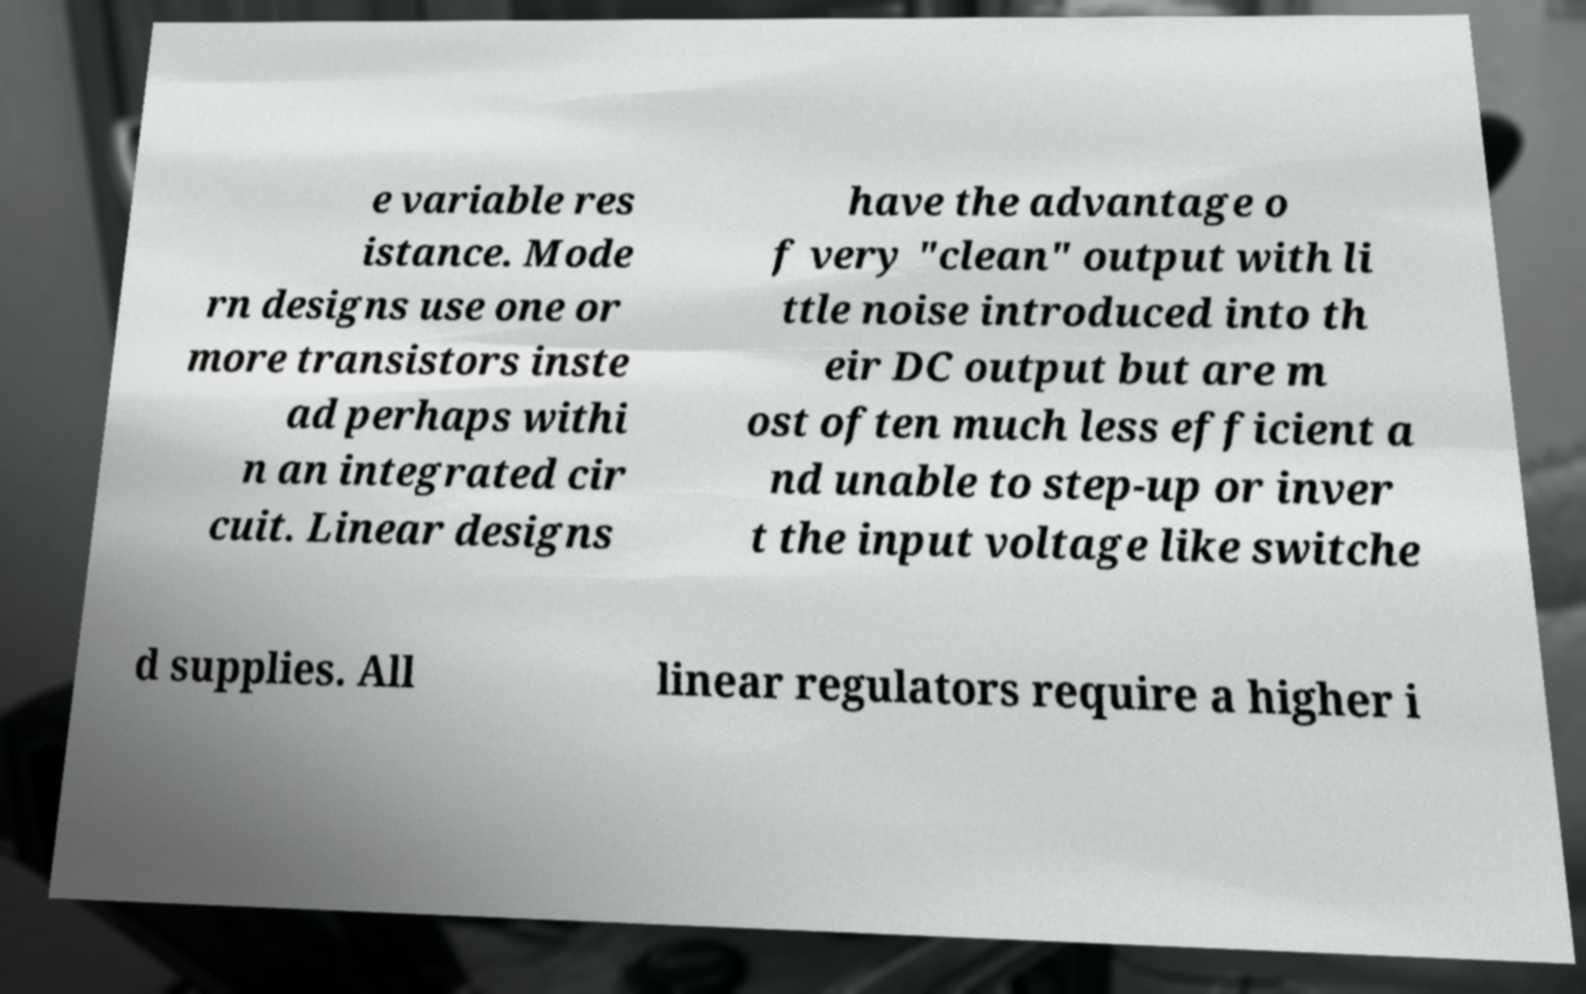Could you extract and type out the text from this image? e variable res istance. Mode rn designs use one or more transistors inste ad perhaps withi n an integrated cir cuit. Linear designs have the advantage o f very "clean" output with li ttle noise introduced into th eir DC output but are m ost often much less efficient a nd unable to step-up or inver t the input voltage like switche d supplies. All linear regulators require a higher i 